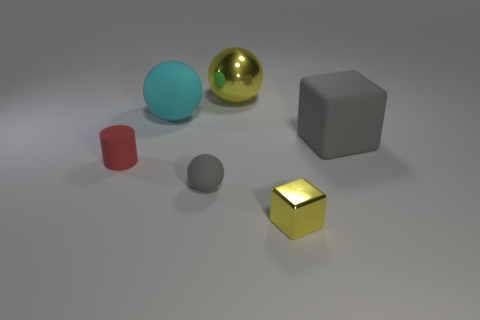Add 2 yellow balls. How many objects exist? 8 Subtract all matte balls. How many balls are left? 1 Subtract all yellow blocks. How many blocks are left? 1 Subtract 0 brown spheres. How many objects are left? 6 Subtract all blocks. How many objects are left? 4 Subtract 2 balls. How many balls are left? 1 Subtract all brown cubes. Subtract all yellow cylinders. How many cubes are left? 2 Subtract all brown spheres. How many blue cubes are left? 0 Subtract all cylinders. Subtract all tiny rubber things. How many objects are left? 3 Add 6 cyan objects. How many cyan objects are left? 7 